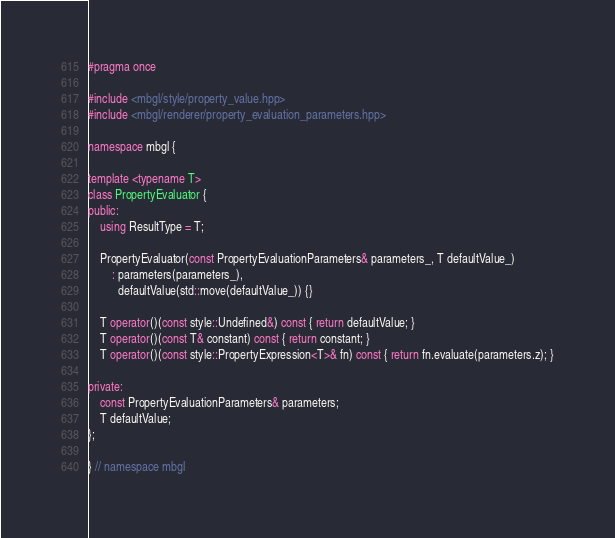<code> <loc_0><loc_0><loc_500><loc_500><_C++_>#pragma once

#include <mbgl/style/property_value.hpp>
#include <mbgl/renderer/property_evaluation_parameters.hpp>

namespace mbgl {

template <typename T>
class PropertyEvaluator {
public:
    using ResultType = T;

    PropertyEvaluator(const PropertyEvaluationParameters& parameters_, T defaultValue_)
        : parameters(parameters_),
          defaultValue(std::move(defaultValue_)) {}

    T operator()(const style::Undefined&) const { return defaultValue; }
    T operator()(const T& constant) const { return constant; }
    T operator()(const style::PropertyExpression<T>& fn) const { return fn.evaluate(parameters.z); }

private:
    const PropertyEvaluationParameters& parameters;
    T defaultValue;
};

} // namespace mbgl
</code> 